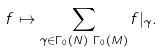<formula> <loc_0><loc_0><loc_500><loc_500>f & \mapsto \sum _ { \gamma \in \Gamma _ { 0 } ( N ) \ \Gamma _ { 0 } ( M ) } f | _ { \gamma } .</formula> 